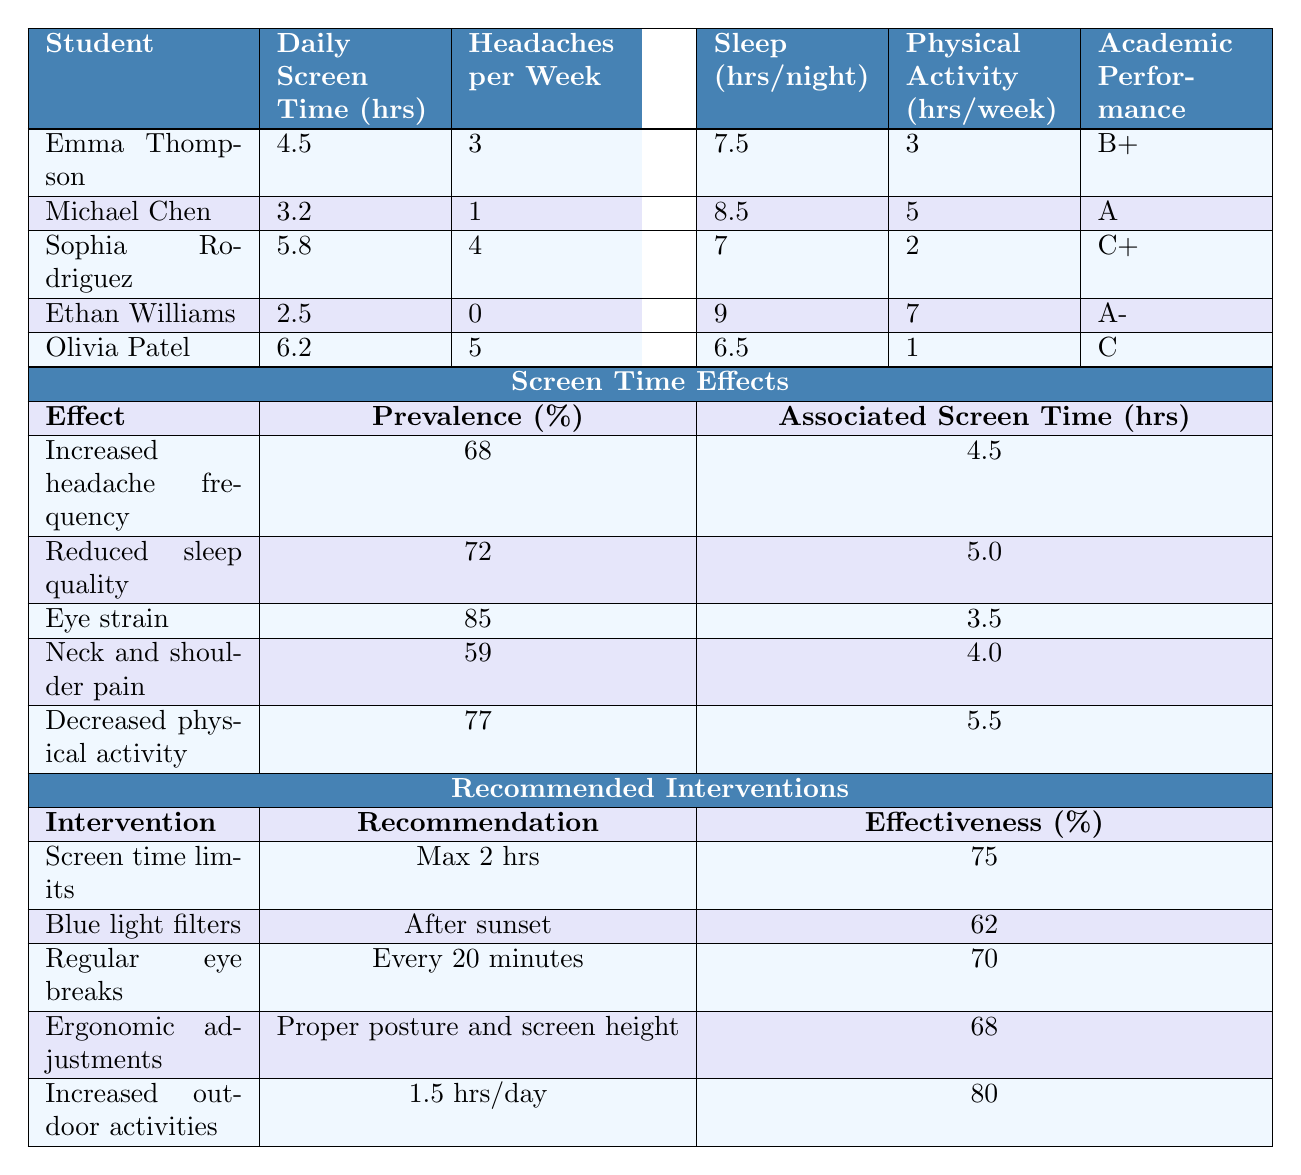What is the daily screen time of Emma Thompson? From the table, I look up Emma Thompson in the student list and find her daily screen time recorded as 4.5 hours.
Answer: 4.5 hours How many headaches does Olivia Patel report per week? By checking the row for Olivia Patel, I see that her reported headaches per week amount to 5.
Answer: 5 headaches Which student has the highest daily screen time? Looking at the daily screen time values in the table, I see that Olivia Patel has the highest screen time at 6.2 hours per day.
Answer: Olivia Patel What is the average headache frequency among the students? To calculate the average headache frequency, I sum the frequencies: 3 + 1 + 4 + 0 + 5 = 13 headaches, and divide by the number of students (5). So, the average is 13/5 = 2.6 headaches per week.
Answer: 2.6 headaches Is there a correlation between high screen time and high headache frequency? I can compare students with high screen times to those with lower ones. Olivia Patel has 6.2 hours and 5 headaches, Emma Thompson has 4.5 hours and 3 headaches, while Ethan Williams has 2.5 hours and 0 headaches, indicating a potential correlation.
Answer: Yes, there seems to be a correlation Which student sleeps the most, and what is their sleep duration? I review the students' sleep hours per night listed in the table and see that Ethan Williams has the highest sleep duration at 9 hours.
Answer: Ethan Williams, 9 hours What percentage of students reported eye strain? From the table, I can see that out of 5 students, 3 reported eye strain (Emma, Sophia, Olivia), which is 60%. Therefore, the answer would be 60%.
Answer: 60% What is the effectiveness percentage of regular eye breaks as an intervention? I look for the row about regular eye breaks in the recommended interventions and find the effectiveness percentage listed as 70%.
Answer: 70% Considering the association of screen time with health effects, how much screen time is associated with decreased physical activity? Referencing the screen time effects section, decreased physical activity is associated with 5.5 hours of screen time.
Answer: 5.5 hours If a student follows the recommended screen time limits, how many hours are they allowed per day? According to the intervention table, the recommendation for screen time limits is a maximum of 2 hours per day.
Answer: 2 hours What common health issues are reported by students with high screen time? I review the headache frequency and physical activity. Both Emma Thompson and Olivia Patel report headaches and lower physical activity hours, indicating health issues associated with high screen time.
Answer: Headaches and decreased physical activity 